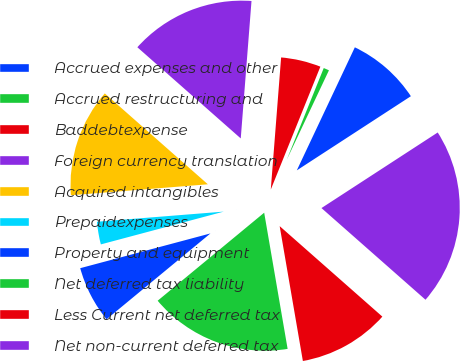Convert chart to OTSL. <chart><loc_0><loc_0><loc_500><loc_500><pie_chart><fcel>Accrued expenses and other<fcel>Accrued restructuring and<fcel>Baddebtexpense<fcel>Foreign currency translation<fcel>Acquired intangibles<fcel>Prepaidexpenses<fcel>Property and equipment<fcel>Net deferred tax liability<fcel>Less Current net deferred tax<fcel>Net non-current deferred tax<nl><fcel>8.81%<fcel>0.91%<fcel>4.86%<fcel>14.74%<fcel>12.77%<fcel>2.88%<fcel>6.84%<fcel>16.72%<fcel>10.79%<fcel>20.67%<nl></chart> 